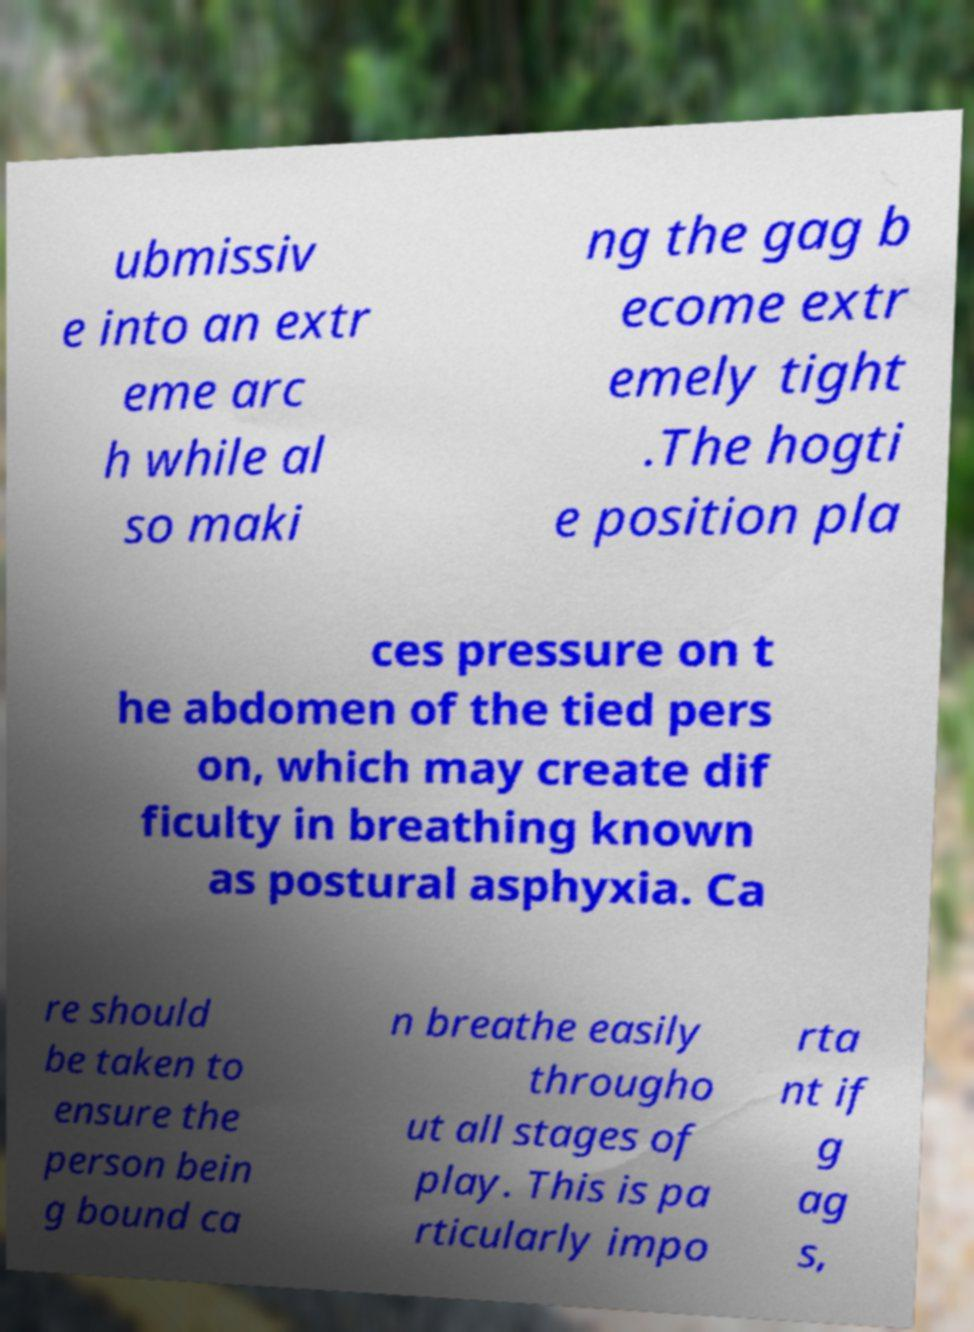Can you read and provide the text displayed in the image?This photo seems to have some interesting text. Can you extract and type it out for me? ubmissiv e into an extr eme arc h while al so maki ng the gag b ecome extr emely tight .The hogti e position pla ces pressure on t he abdomen of the tied pers on, which may create dif ficulty in breathing known as postural asphyxia. Ca re should be taken to ensure the person bein g bound ca n breathe easily througho ut all stages of play. This is pa rticularly impo rta nt if g ag s, 